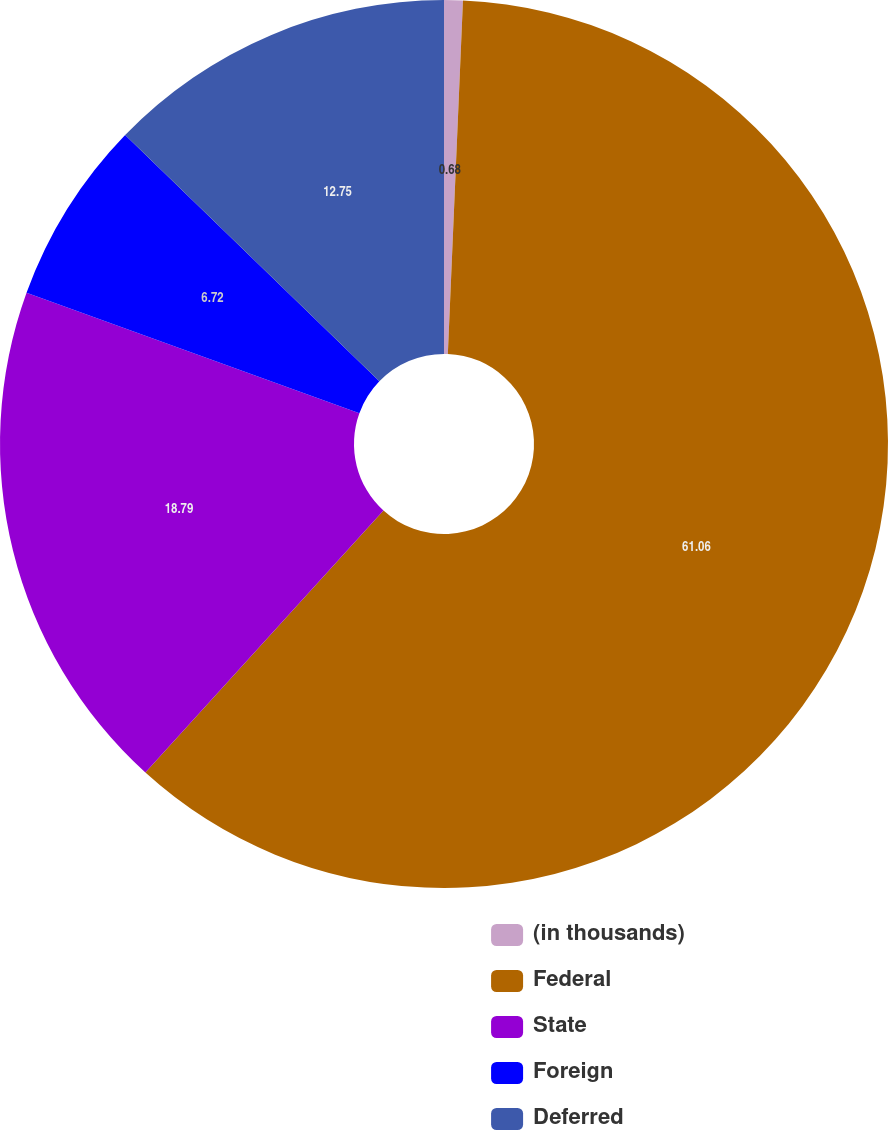<chart> <loc_0><loc_0><loc_500><loc_500><pie_chart><fcel>(in thousands)<fcel>Federal<fcel>State<fcel>Foreign<fcel>Deferred<nl><fcel>0.68%<fcel>61.06%<fcel>18.79%<fcel>6.72%<fcel>12.75%<nl></chart> 